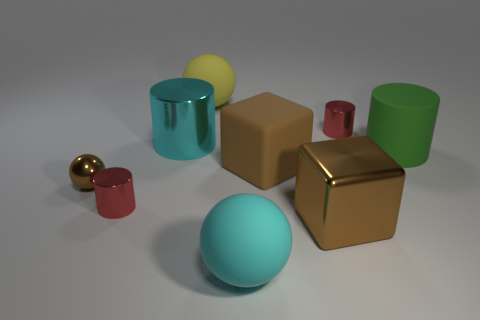Subtract all tiny metallic spheres. How many spheres are left? 2 Subtract all green cylinders. How many cylinders are left? 3 Subtract 1 cylinders. How many cylinders are left? 3 Subtract all brown cylinders. Subtract all brown cubes. How many cylinders are left? 4 Subtract all cylinders. How many objects are left? 5 Subtract all tiny cylinders. Subtract all tiny brown shiny balls. How many objects are left? 6 Add 9 big cyan cylinders. How many big cyan cylinders are left? 10 Add 6 red metal balls. How many red metal balls exist? 6 Subtract 0 gray balls. How many objects are left? 9 